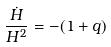<formula> <loc_0><loc_0><loc_500><loc_500>\frac { \dot { H } } { H ^ { 2 } } = - ( 1 + q )</formula> 